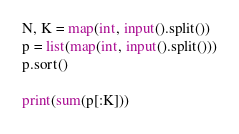Convert code to text. <code><loc_0><loc_0><loc_500><loc_500><_Python_>N, K = map(int, input().split())
p = list(map(int, input().split()))
p.sort()

print(sum(p[:K]))
</code> 